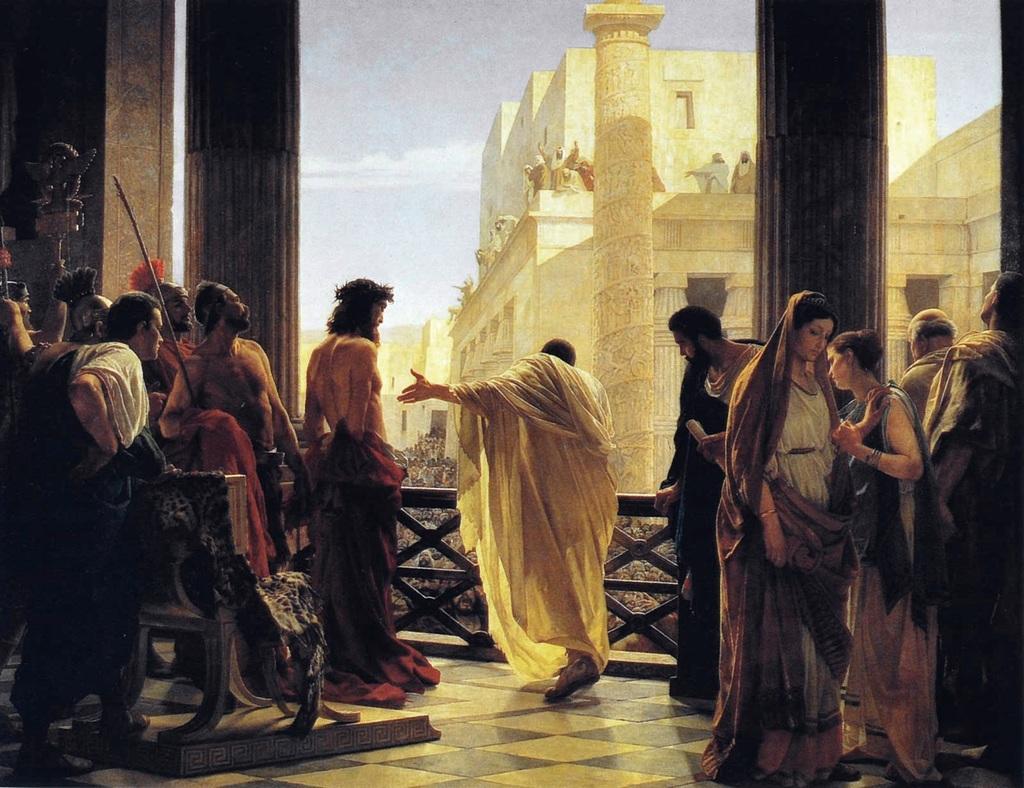Can you describe this image briefly? This is a painting in this image there are people inside a building, in the background there are buildings and a sky. 